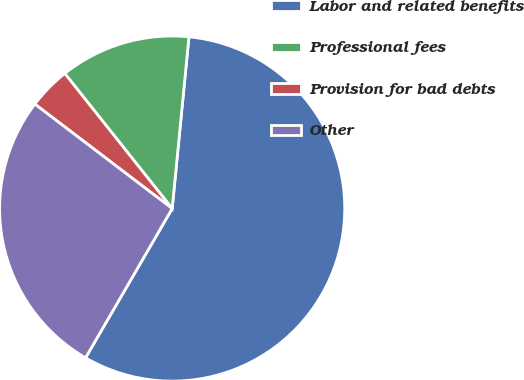<chart> <loc_0><loc_0><loc_500><loc_500><pie_chart><fcel>Labor and related benefits<fcel>Professional fees<fcel>Provision for bad debts<fcel>Other<nl><fcel>56.82%<fcel>12.24%<fcel>3.96%<fcel>26.98%<nl></chart> 